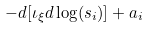<formula> <loc_0><loc_0><loc_500><loc_500>- d [ \iota _ { \xi } d \log ( s _ { i } ) ] + a _ { i }</formula> 